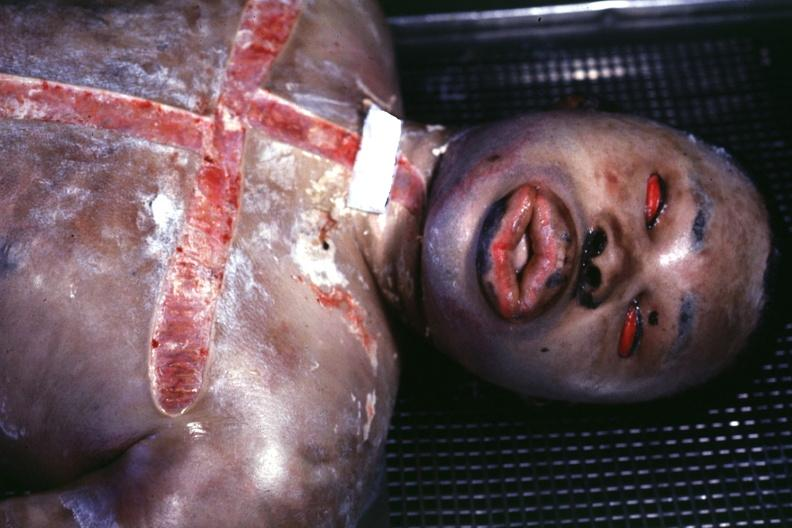s view of face showing grotesque edema?
Answer the question using a single word or phrase. Yes 